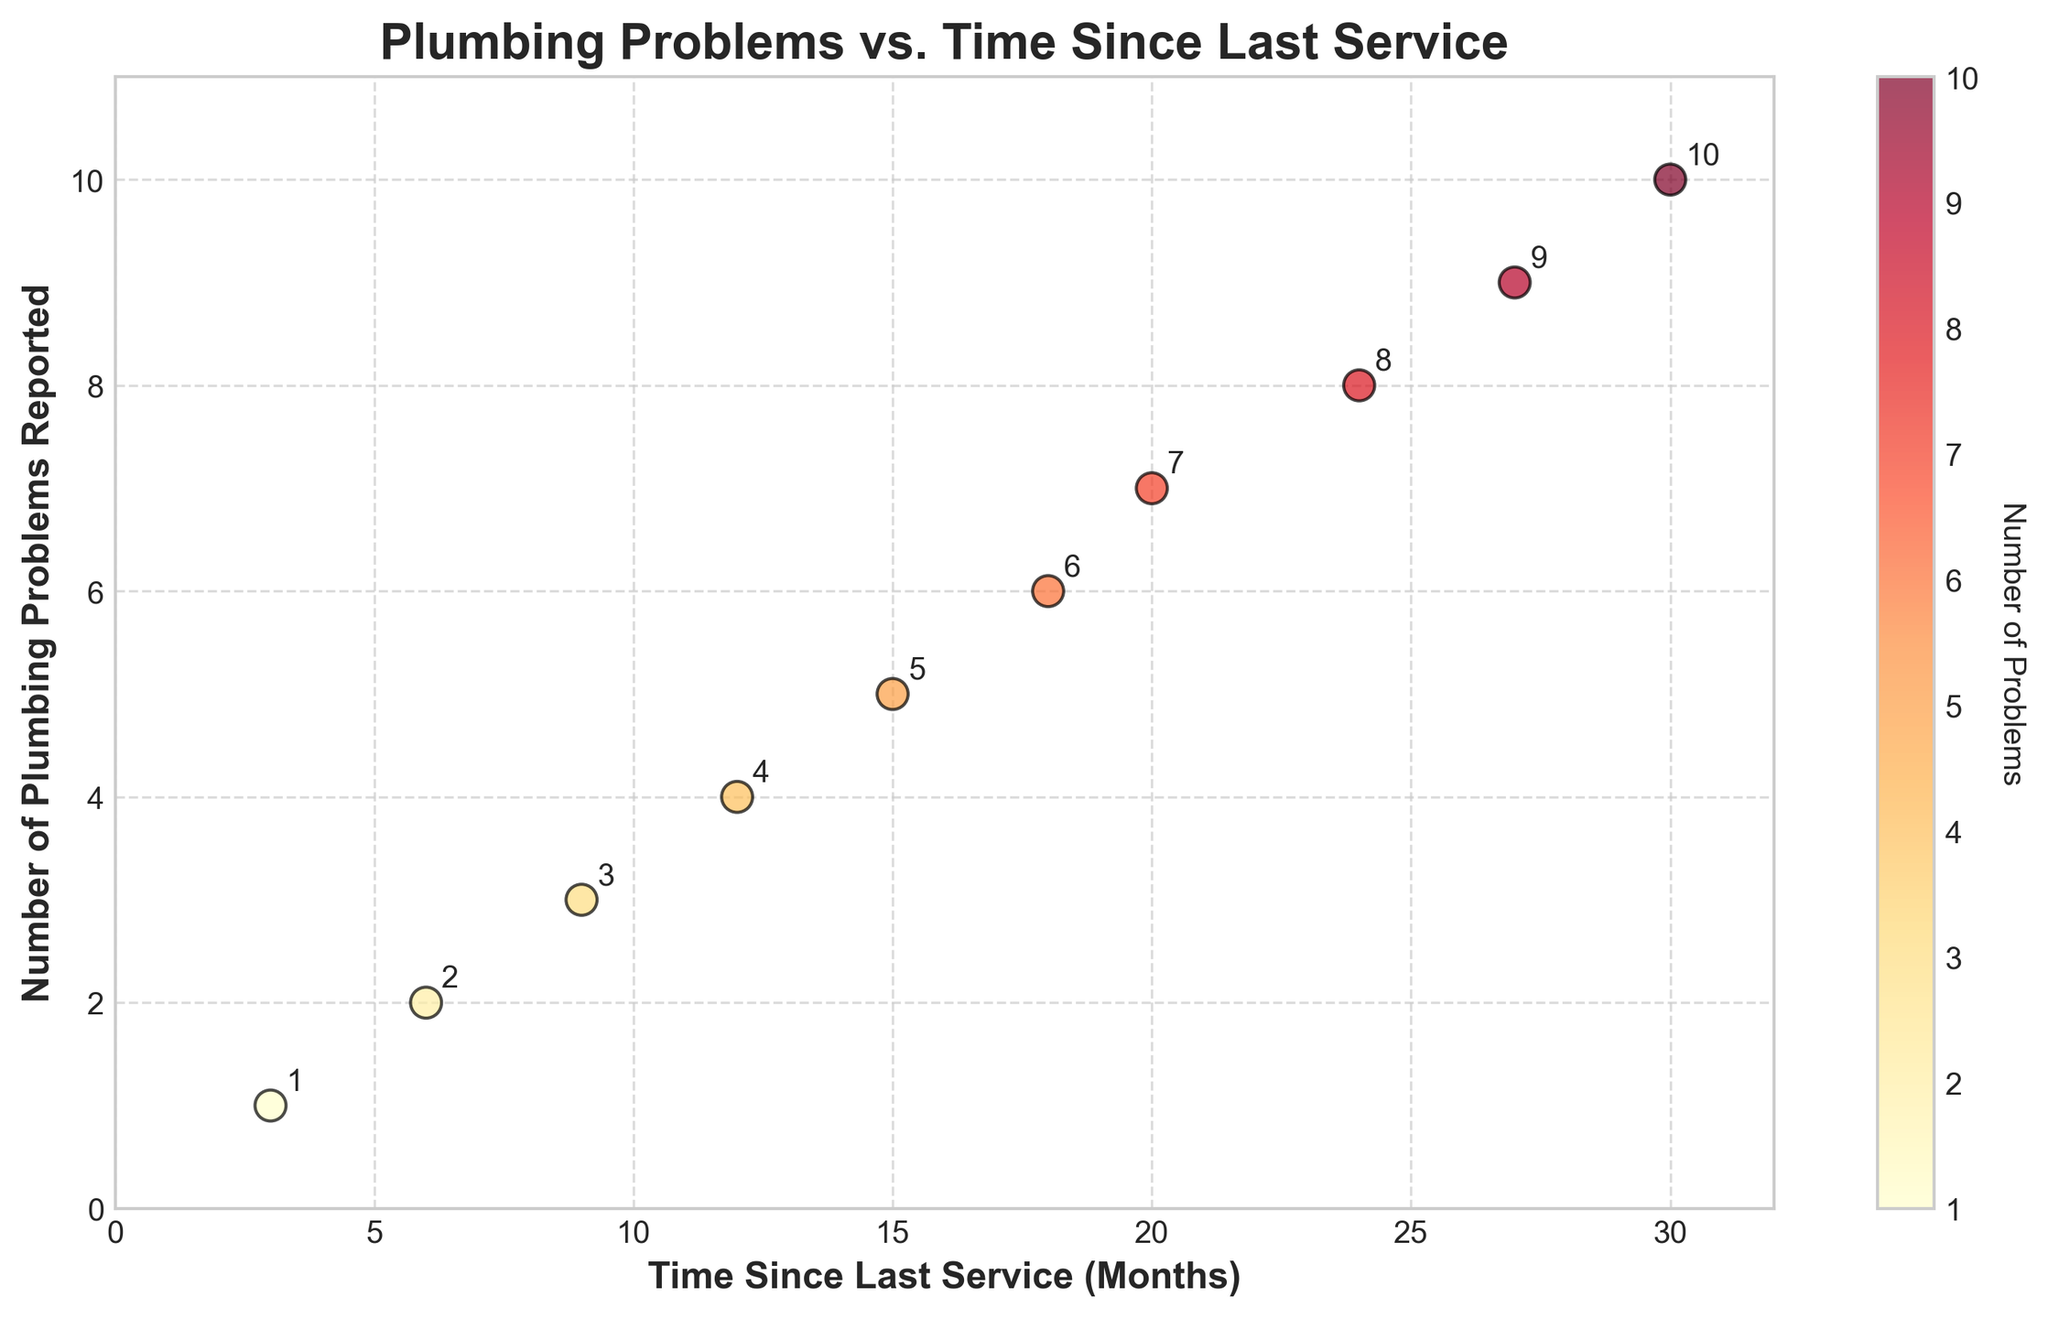What is the title of the plot? The title of the plot is prominently displayed at the top and provides a summary of the data being visualized.
Answer: Plumbing Problems vs. Time Since Last Service How does the number of reported plumbing problems change with the time since the last service? As the time since the last service increases, the number of plumbing problems reported also increases. This is observed as a positive trend in the scatter plot.
Answer: Increasing What are the labels for the x-axis and y-axis? The labels for the axes are shown beside each axis. The x-axis label is 'Time Since Last Service (Months)' and the y-axis label is 'Number of Plumbing Problems Reported'.
Answer: Time Since Last Service (Months) and Number of Plumbing Problems Reported How many data points are there in the plot? The number of data points can be counted from the plot; each point represents a pair of values.
Answer: 10 Which data point represents the maximum number of plumbing problems reported, and at how many months did this occur? The data point with the highest y-value represents the maximum number of plumbing problems. This occurs at the highest value on the y-axis.
Answer: 30 months, 10 problems What is the average number of plumbing problems reported? To calculate the average, sum all the y-values and divide by the number of data points. (1+2+3+4+5+6+7+8+9+10)/10 = 55/10 = 5.5
Answer: 5.5 At which time since the last service were three plumbing problems reported? Identifying the x-value for the y-value of 3 requires looking at the points and labels.
Answer: 9 months Do any points have the same number of reported plumbing problems? Each point represents a unique (x, y) pair, so no two points share the same y-value based on observation.
Answer: No Describe the color pattern used in the scatter plot. The color gradually intensifies from yellow to red as the number of problems increases, indicating a color gradient from fewer to more problems.
Answer: Yellow to Red Gradient How does the scatter plot visually indicate the number of plumbing problems reported? The plot uses color intensity and size proportionally; points with a higher number of problems are darker and larger.
Answer: Intensity and Size 